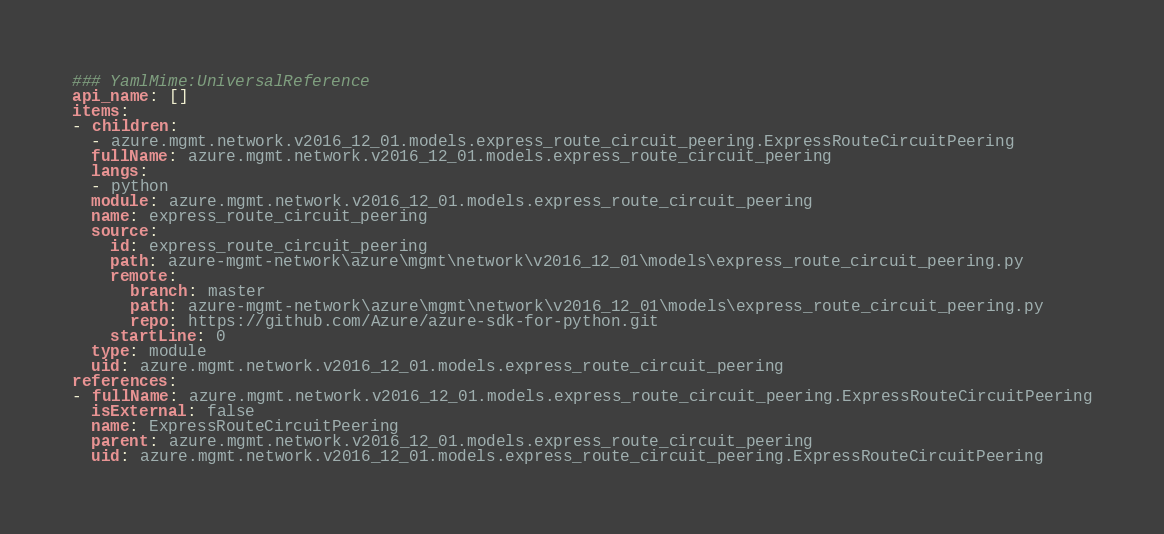<code> <loc_0><loc_0><loc_500><loc_500><_YAML_>### YamlMime:UniversalReference
api_name: []
items:
- children:
  - azure.mgmt.network.v2016_12_01.models.express_route_circuit_peering.ExpressRouteCircuitPeering
  fullName: azure.mgmt.network.v2016_12_01.models.express_route_circuit_peering
  langs:
  - python
  module: azure.mgmt.network.v2016_12_01.models.express_route_circuit_peering
  name: express_route_circuit_peering
  source:
    id: express_route_circuit_peering
    path: azure-mgmt-network\azure\mgmt\network\v2016_12_01\models\express_route_circuit_peering.py
    remote:
      branch: master
      path: azure-mgmt-network\azure\mgmt\network\v2016_12_01\models\express_route_circuit_peering.py
      repo: https://github.com/Azure/azure-sdk-for-python.git
    startLine: 0
  type: module
  uid: azure.mgmt.network.v2016_12_01.models.express_route_circuit_peering
references:
- fullName: azure.mgmt.network.v2016_12_01.models.express_route_circuit_peering.ExpressRouteCircuitPeering
  isExternal: false
  name: ExpressRouteCircuitPeering
  parent: azure.mgmt.network.v2016_12_01.models.express_route_circuit_peering
  uid: azure.mgmt.network.v2016_12_01.models.express_route_circuit_peering.ExpressRouteCircuitPeering
</code> 